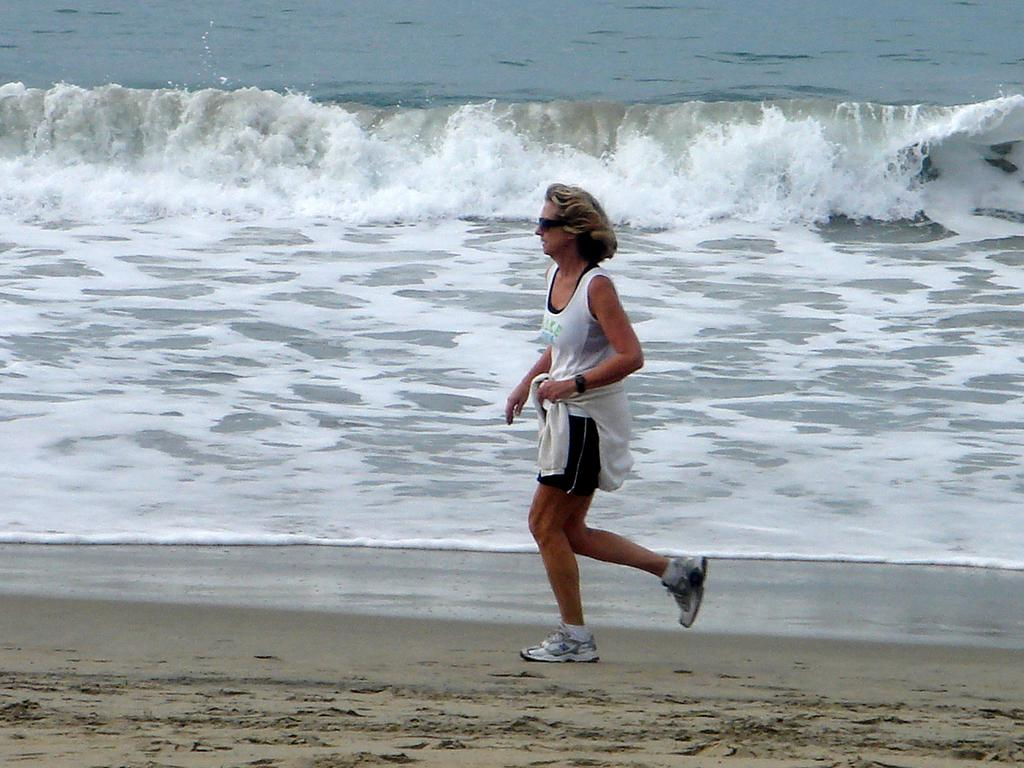What is the main subject of the image? There is a woman walking in the image. Where is the woman located in the image? The woman is in the center of the image. What can be seen in the background of the image? There is an ocean in the background of the image. What type of terrain is visible in the image? There is sand visible in the image. What type of vase can be seen on the railway in the image? There is no railway or vase present in the image; it features a woman walking near an ocean. What rhythm is the woman walking to in the image? The image does not provide information about the rhythm of the woman's walk. 